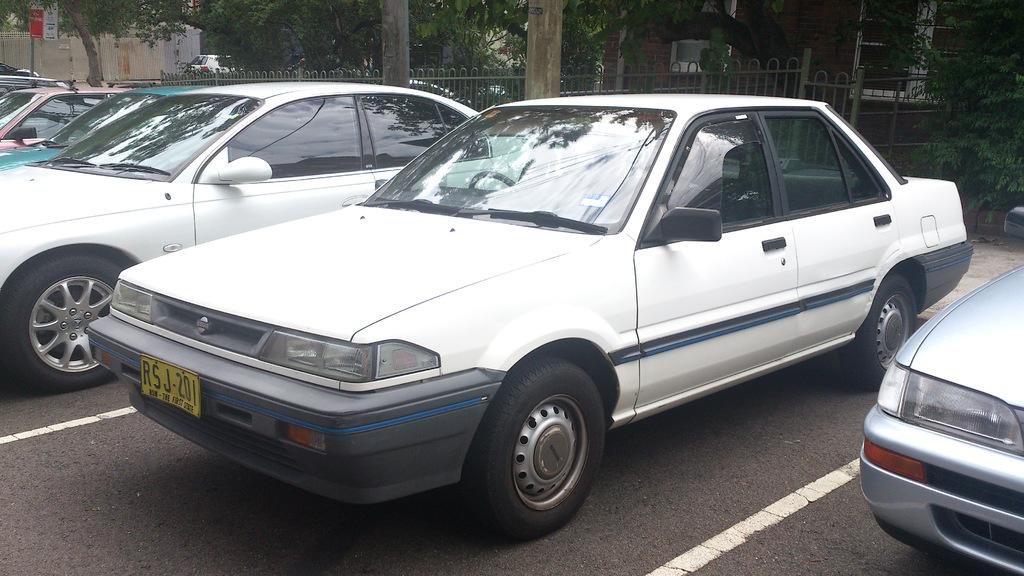What can be seen on the road in the image? Cars are parked on the road in the image. What is visible in the background of the image? There is fencing and trees in the background of the image. What type of pan is hanging from the tree in the image? There is no pan present in the image; it only features parked cars, fencing, and trees in the background. 